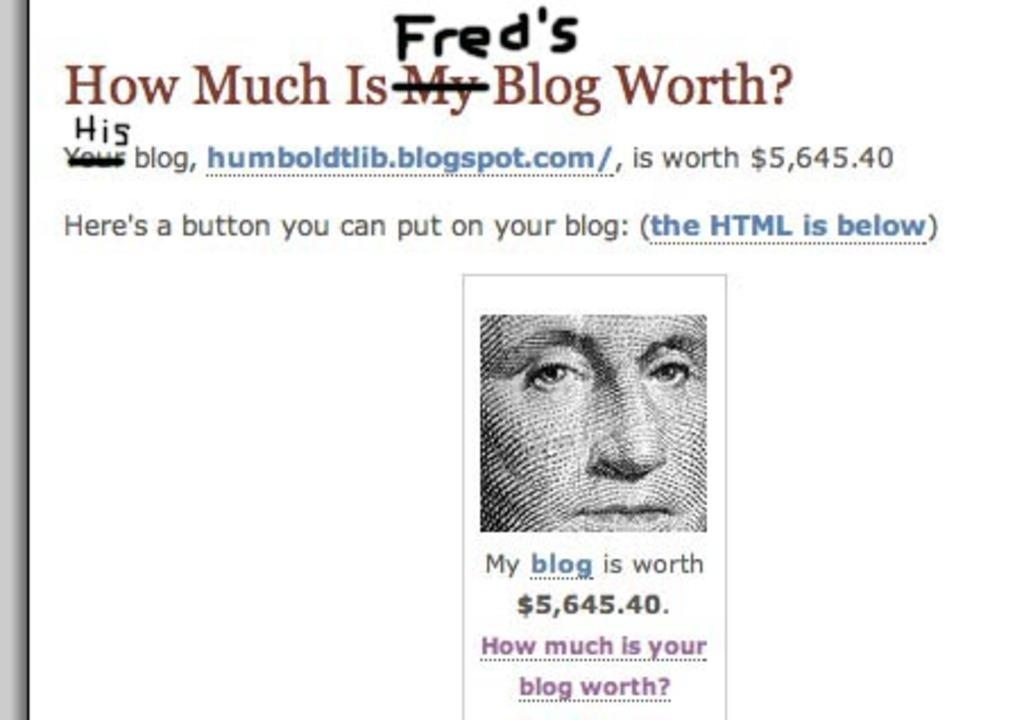What can be found in the image that contains written information? There is text in the image. What is shown in the image besides the text? There is a depiction of a person in the image. What color is the background of the image? The background of the image is white. How many rings are visible on the person's fingers in the image? There are no rings visible on the person's fingers in the image. What type of shade is covering the person in the image? There is no shade present in the image; the background is white. 